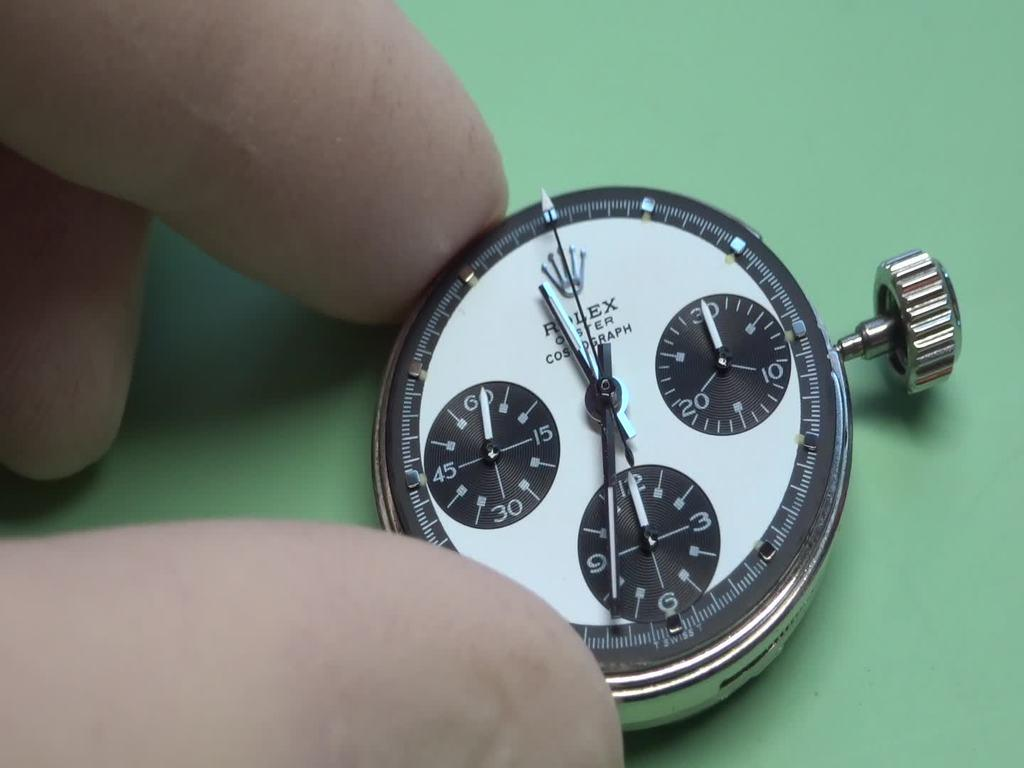What part of a person's body is visible in the image? There are fingers visible in the image. What are the fingers holding? The fingers are holding a dial of a watch. What color is the background in the image? The background in the image is green. What invention is the person using to draw attention in the image? There is no invention or indication of drawing attention in the image; it simply shows a person's fingers holding a watch dial. 